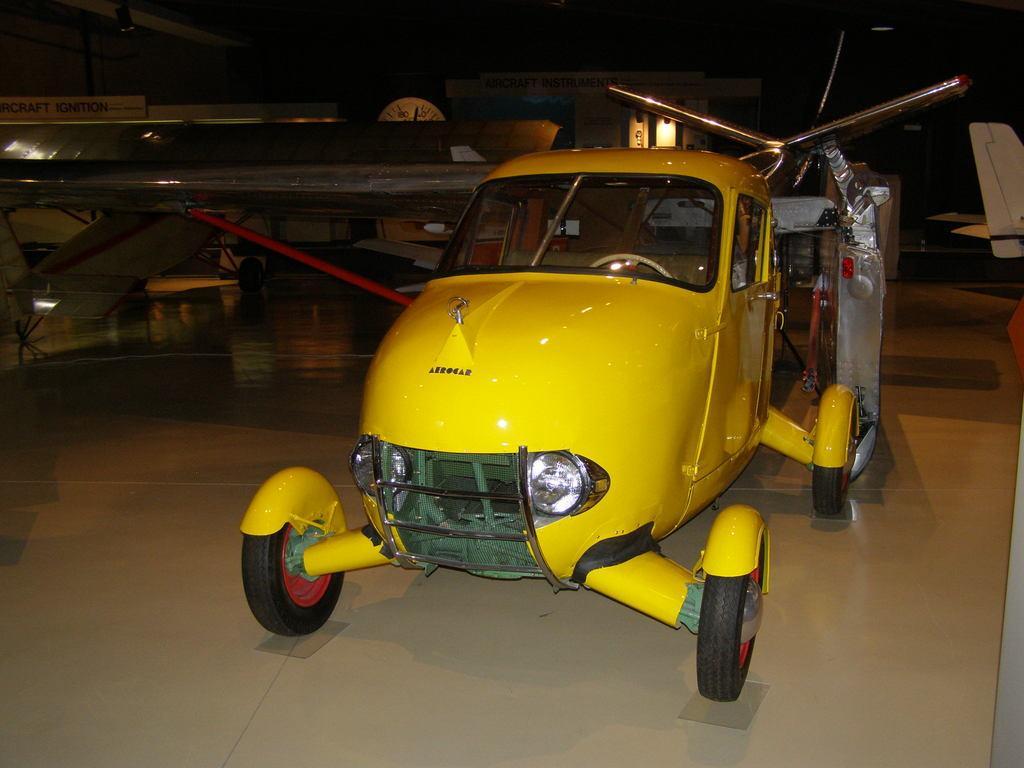How would you summarize this image in a sentence or two? Here we can see helicopters. This is tile floor. Background we can see board, lights and clock. 